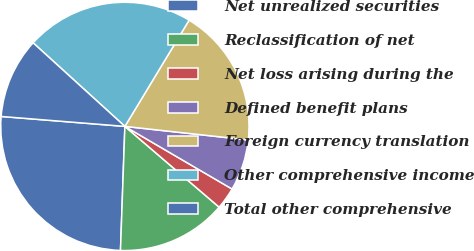Convert chart. <chart><loc_0><loc_0><loc_500><loc_500><pie_chart><fcel>Net unrealized securities<fcel>Reclassification of net<fcel>Net loss arising during the<fcel>Defined benefit plans<fcel>Foreign currency translation<fcel>Other comprehensive income<fcel>Total other comprehensive<nl><fcel>25.71%<fcel>14.29%<fcel>2.86%<fcel>6.67%<fcel>18.09%<fcel>21.9%<fcel>10.48%<nl></chart> 